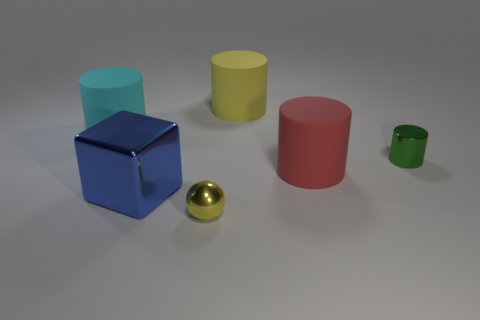Subtract all cyan matte cylinders. How many cylinders are left? 3 Subtract all brown cylinders. Subtract all purple cubes. How many cylinders are left? 4 Add 1 tiny purple cubes. How many objects exist? 7 Subtract all cylinders. How many objects are left? 2 Add 4 big blue metal things. How many big blue metal things are left? 5 Add 6 blue metal cubes. How many blue metal cubes exist? 7 Subtract 1 blue blocks. How many objects are left? 5 Subtract all big blue metal balls. Subtract all tiny shiny things. How many objects are left? 4 